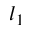<formula> <loc_0><loc_0><loc_500><loc_500>l _ { 1 }</formula> 